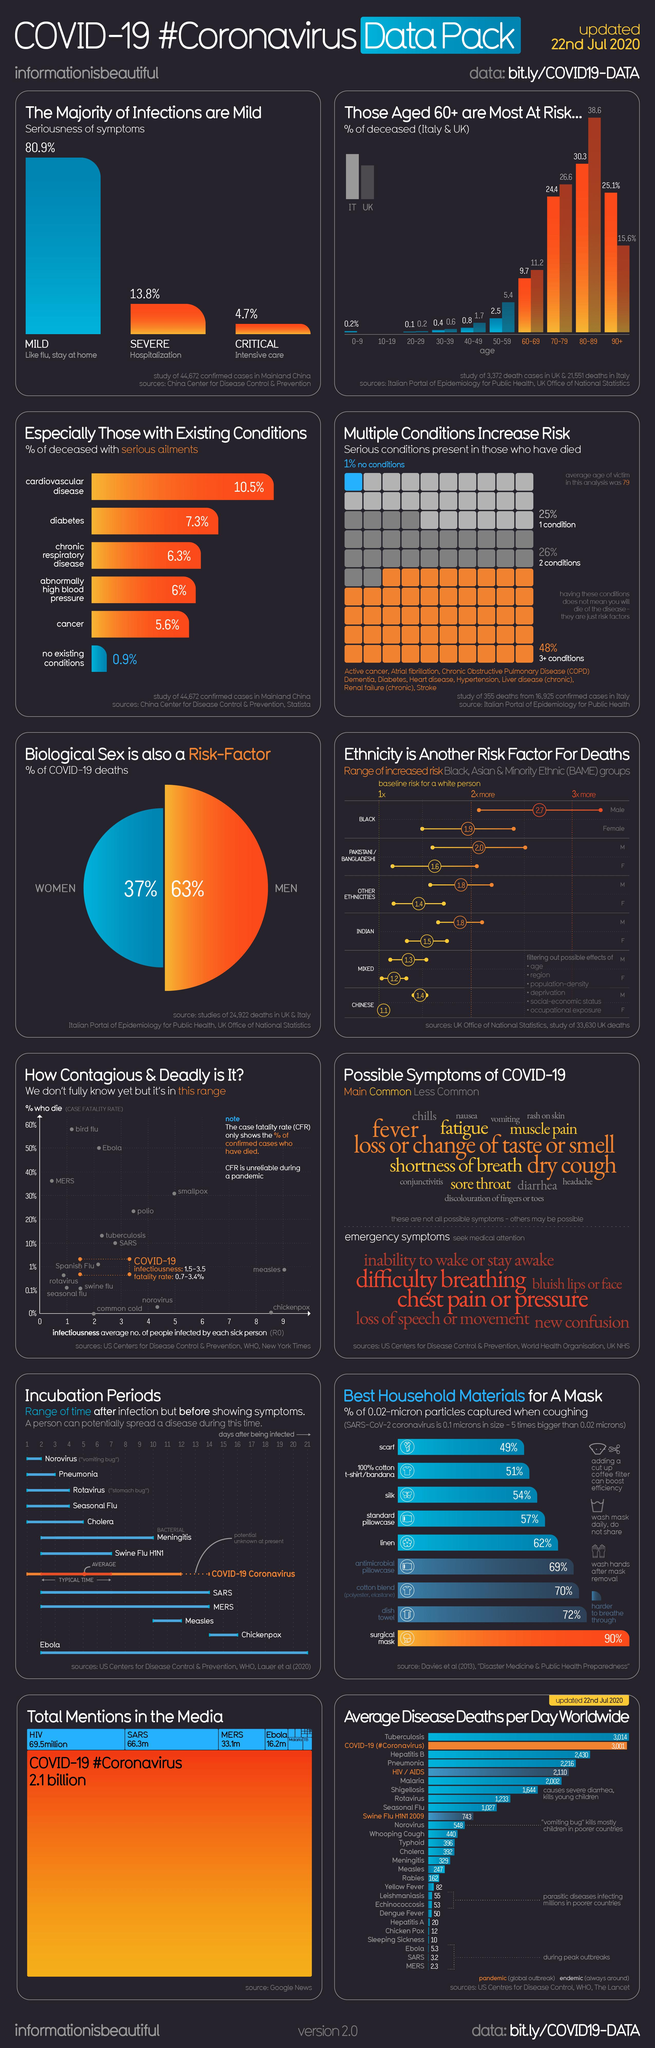Point out several critical features in this image. The Corona severity is classified into three categories: mild, severe, and critical. The infographic lists the following global pandemic diseases: COVID-19 (Coronavirus), HIV/AIDS, and Swine Flu H1N1 2009. The maximum number of people who can be infected by a COVID-19 patient is approximately 3.5. Diabetes is the second most common coronavirus symptom that can lead to death. The second group of people with the highest percentage of risk of death were affected by multiple conditions. 